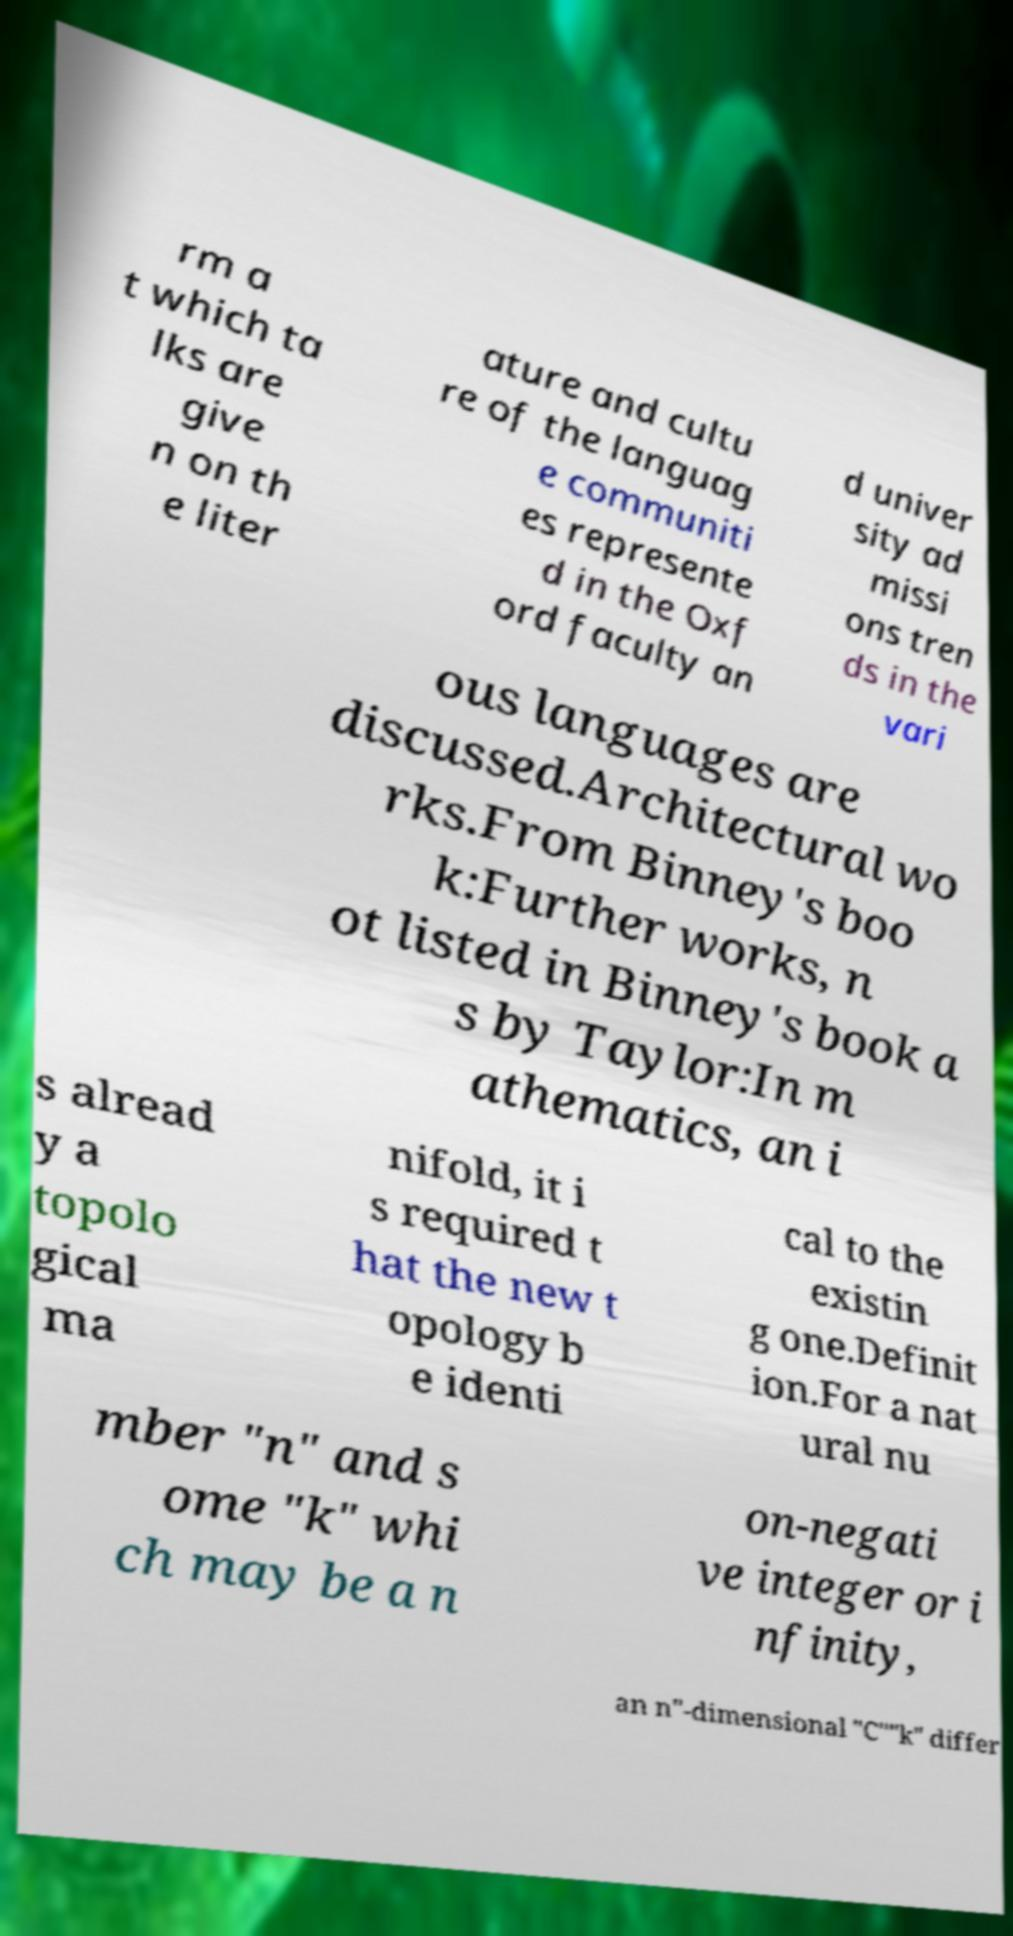What messages or text are displayed in this image? I need them in a readable, typed format. rm a t which ta lks are give n on th e liter ature and cultu re of the languag e communiti es represente d in the Oxf ord faculty an d univer sity ad missi ons tren ds in the vari ous languages are discussed.Architectural wo rks.From Binney's boo k:Further works, n ot listed in Binney's book a s by Taylor:In m athematics, an i s alread y a topolo gical ma nifold, it i s required t hat the new t opology b e identi cal to the existin g one.Definit ion.For a nat ural nu mber "n" and s ome "k" whi ch may be a n on-negati ve integer or i nfinity, an n"-dimensional "C""k" differ 